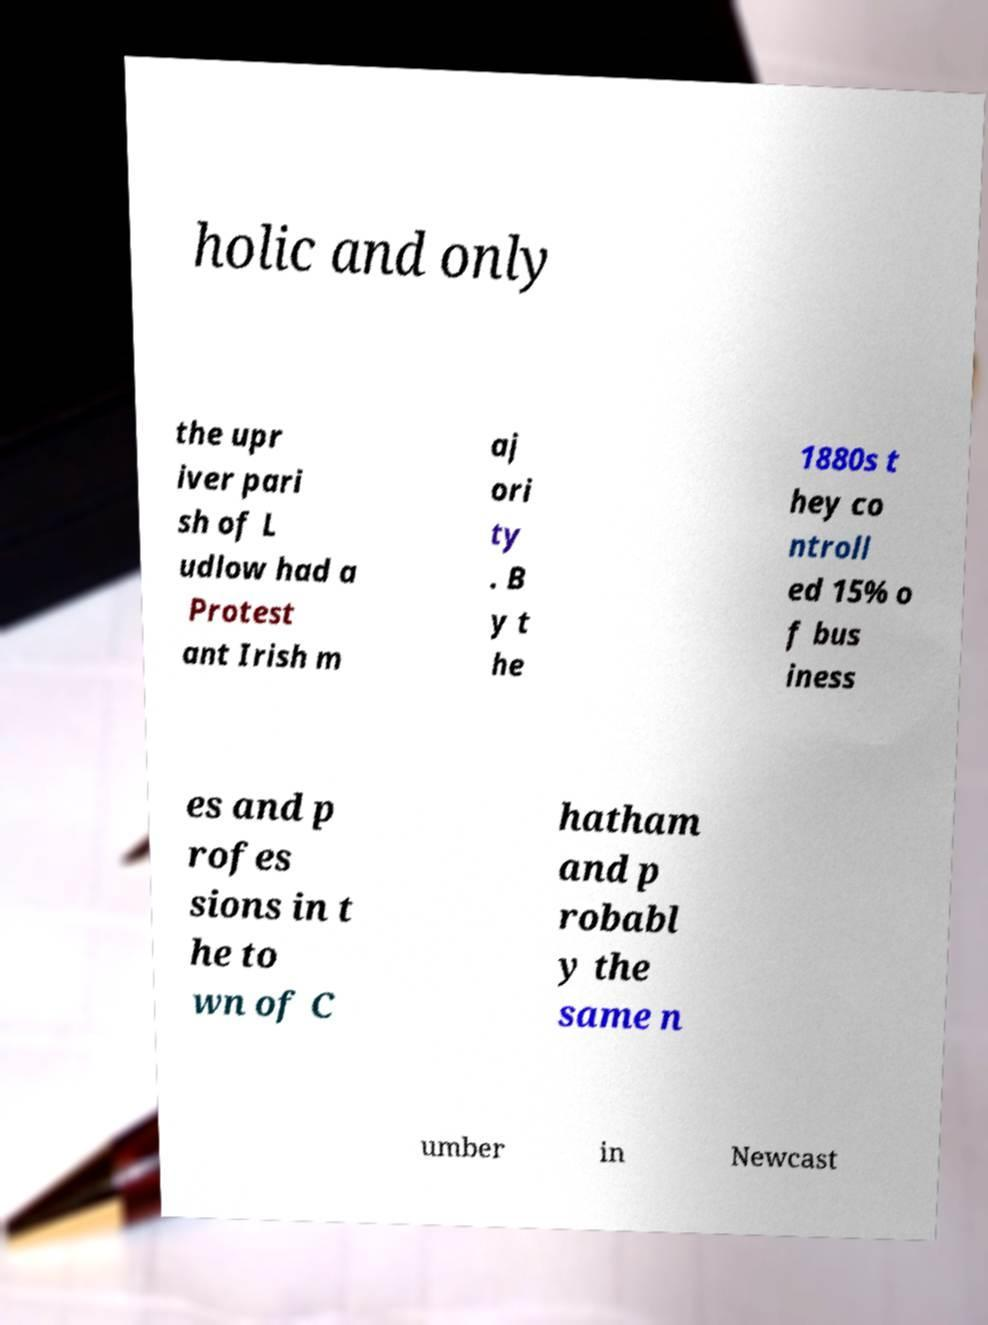Could you assist in decoding the text presented in this image and type it out clearly? holic and only the upr iver pari sh of L udlow had a Protest ant Irish m aj ori ty . B y t he 1880s t hey co ntroll ed 15% o f bus iness es and p rofes sions in t he to wn of C hatham and p robabl y the same n umber in Newcast 